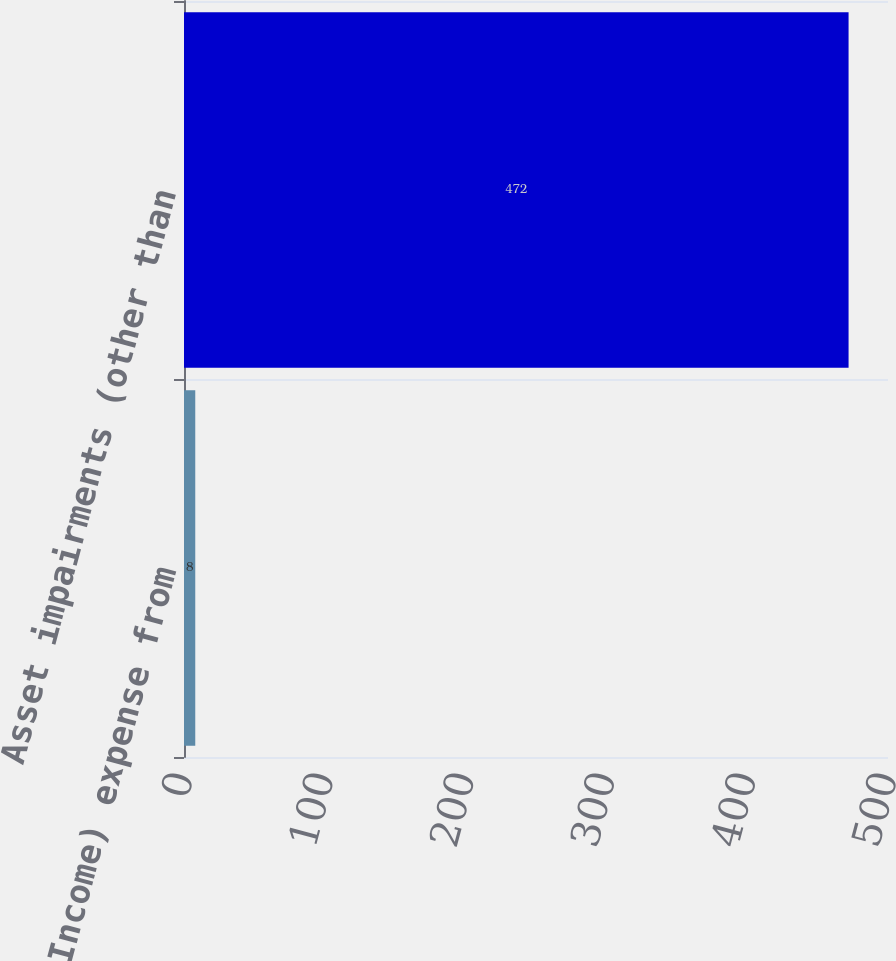<chart> <loc_0><loc_0><loc_500><loc_500><bar_chart><fcel>(Income) expense from<fcel>Asset impairments (other than<nl><fcel>8<fcel>472<nl></chart> 